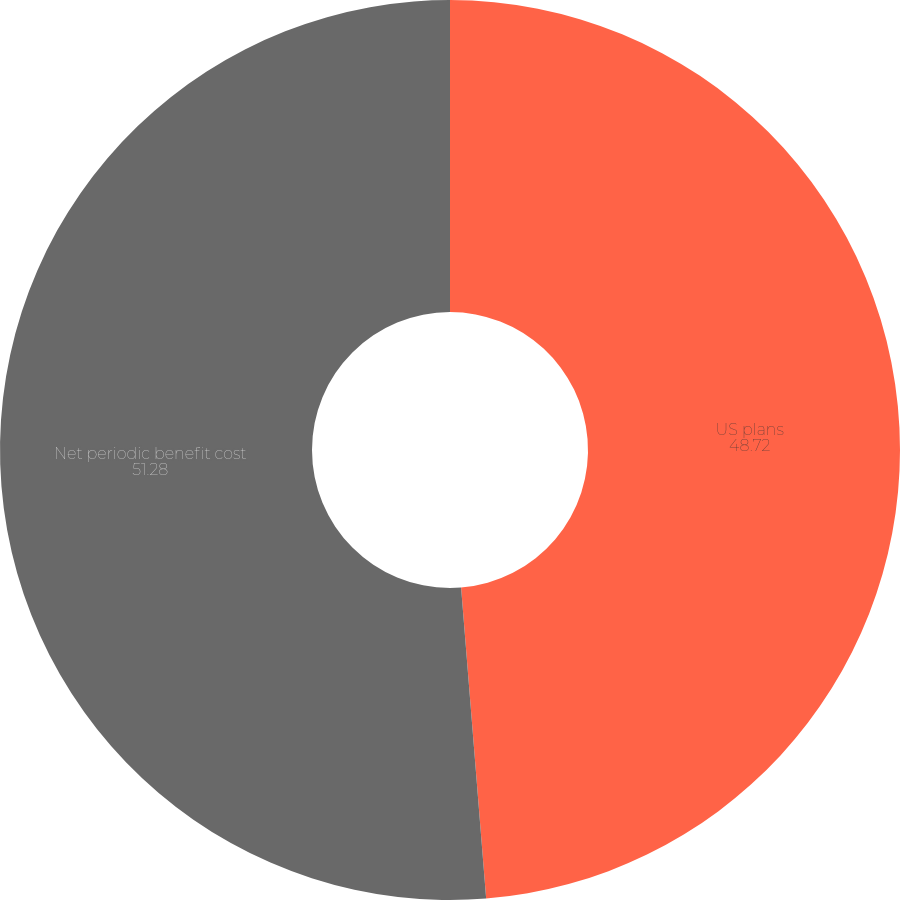Convert chart. <chart><loc_0><loc_0><loc_500><loc_500><pie_chart><fcel>US plans<fcel>Net periodic benefit cost<nl><fcel>48.72%<fcel>51.28%<nl></chart> 